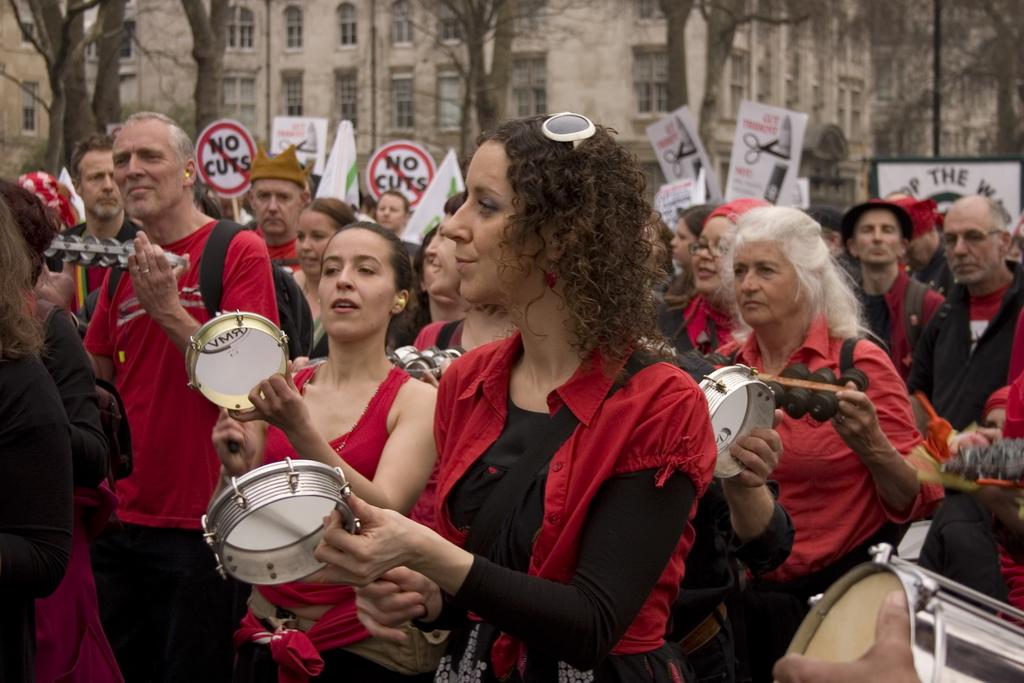How many people are in the image? There is a group of people in the image. What are the people doing in the image? The people are standing. What are the people holding in their hands? The people are holding drums in their hands. What can be seen in the background of the image? There are banners, a building with windows, trees, and a pole in the background of the image. What type of legal advice is the lawyer providing to the group in the image? There is no lawyer present in the image, and therefore no legal advice is being provided. 